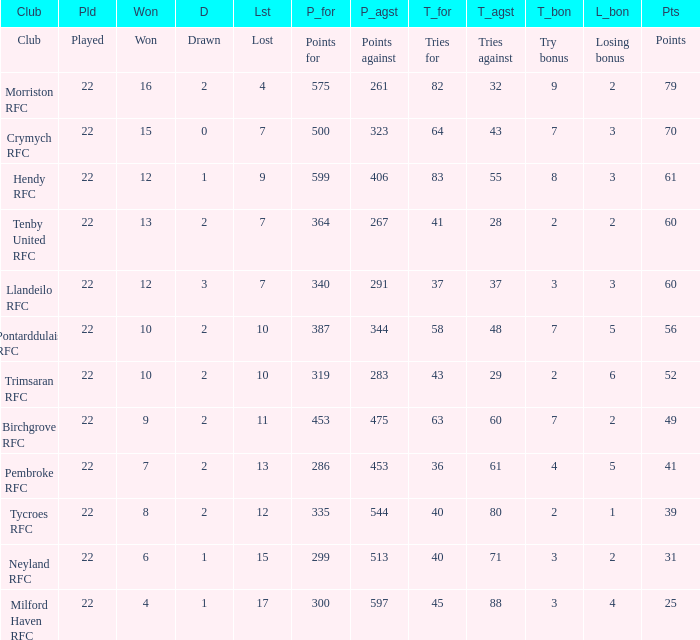What's the points with tries for being 64 70.0. 